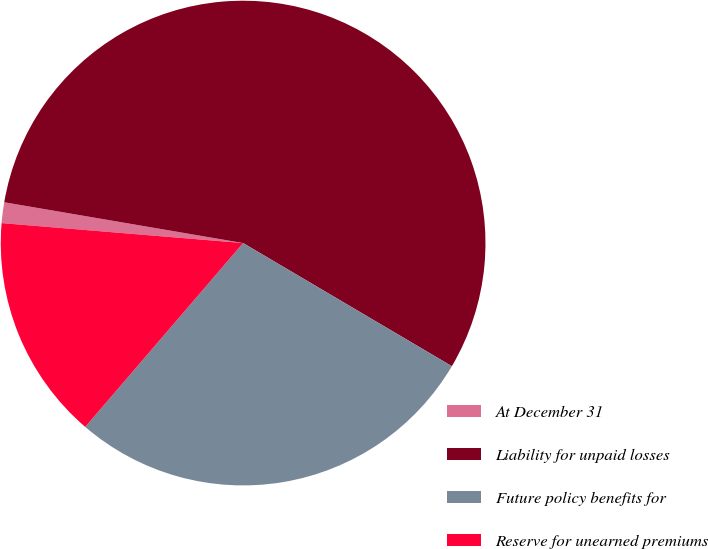Convert chart. <chart><loc_0><loc_0><loc_500><loc_500><pie_chart><fcel>At December 31<fcel>Liability for unpaid losses<fcel>Future policy benefits for<fcel>Reserve for unearned premiums<nl><fcel>1.38%<fcel>55.79%<fcel>27.81%<fcel>15.02%<nl></chart> 